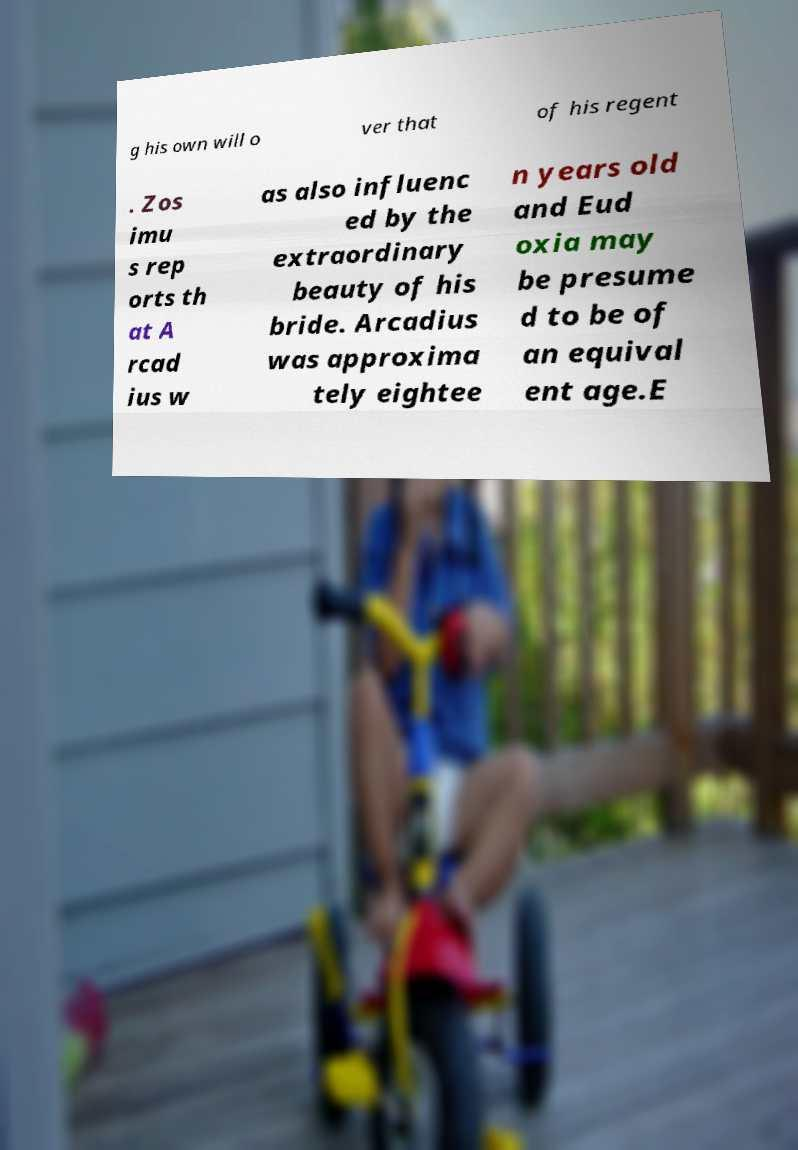For documentation purposes, I need the text within this image transcribed. Could you provide that? g his own will o ver that of his regent . Zos imu s rep orts th at A rcad ius w as also influenc ed by the extraordinary beauty of his bride. Arcadius was approxima tely eightee n years old and Eud oxia may be presume d to be of an equival ent age.E 